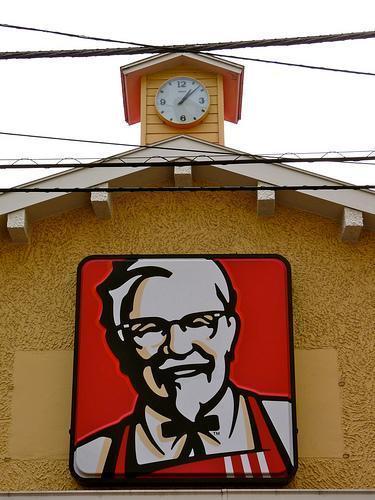How many numbers are on the clock?
Give a very brief answer. 4. 